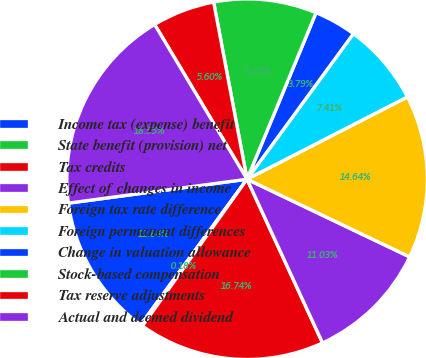<chart> <loc_0><loc_0><loc_500><loc_500><pie_chart><fcel>Income tax (expense) benefit<fcel>State benefit (provision) net<fcel>Tax credits<fcel>Effect of changes in income<fcel>Foreign tax rate difference<fcel>Foreign permanent differences<fcel>Change in valuation allowance<fcel>Stock-based compensation<fcel>Tax reserve adjustments<fcel>Actual and deemed dividend<nl><fcel>12.84%<fcel>0.18%<fcel>16.74%<fcel>11.03%<fcel>14.64%<fcel>7.41%<fcel>3.79%<fcel>9.22%<fcel>5.6%<fcel>18.55%<nl></chart> 